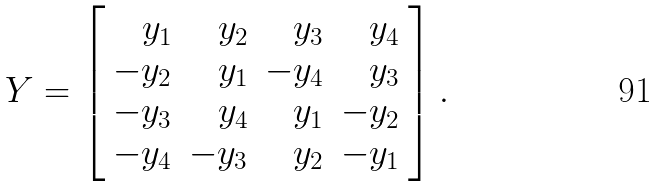Convert formula to latex. <formula><loc_0><loc_0><loc_500><loc_500>Y = \left [ \begin{array} { r r r r } y _ { 1 } & y _ { 2 } & y _ { 3 } & y _ { 4 } \\ - y _ { 2 } & y _ { 1 } & - y _ { 4 } & y _ { 3 } \\ - y _ { 3 } & y _ { 4 } & y _ { 1 } & - y _ { 2 } \\ - y _ { 4 } & - y _ { 3 } & y _ { 2 } & - y _ { 1 } \\ \end{array} \right ] .</formula> 